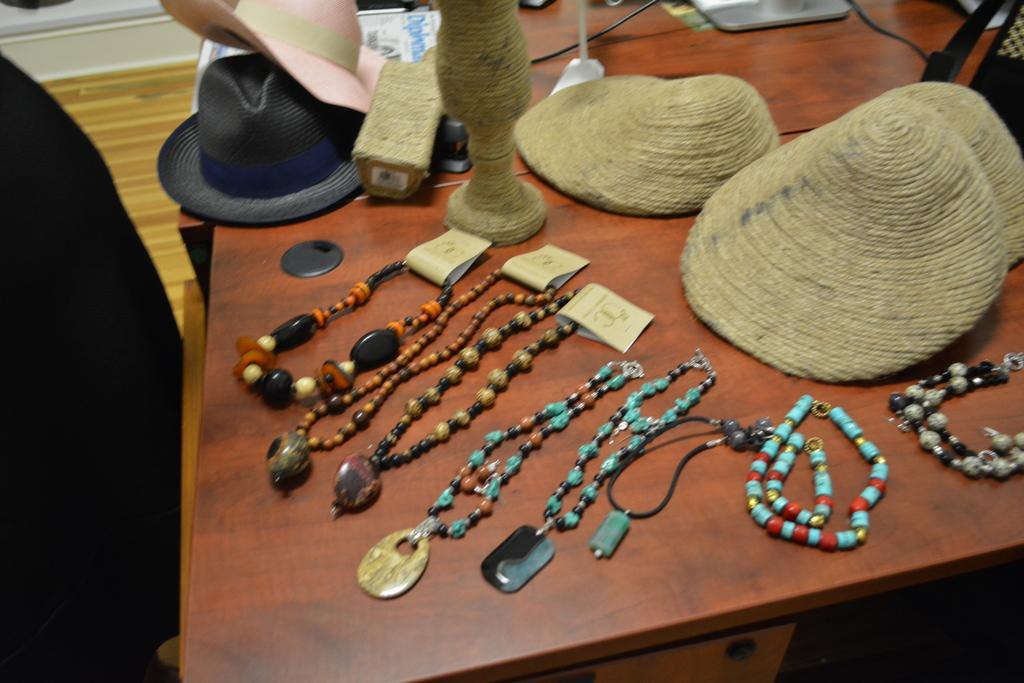Can you describe this image briefly? This picture shows couple of hats and ornaments and few papers on the table. 